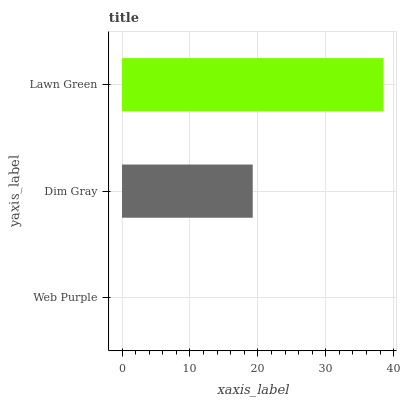Is Web Purple the minimum?
Answer yes or no. Yes. Is Lawn Green the maximum?
Answer yes or no. Yes. Is Dim Gray the minimum?
Answer yes or no. No. Is Dim Gray the maximum?
Answer yes or no. No. Is Dim Gray greater than Web Purple?
Answer yes or no. Yes. Is Web Purple less than Dim Gray?
Answer yes or no. Yes. Is Web Purple greater than Dim Gray?
Answer yes or no. No. Is Dim Gray less than Web Purple?
Answer yes or no. No. Is Dim Gray the high median?
Answer yes or no. Yes. Is Dim Gray the low median?
Answer yes or no. Yes. Is Web Purple the high median?
Answer yes or no. No. Is Lawn Green the low median?
Answer yes or no. No. 